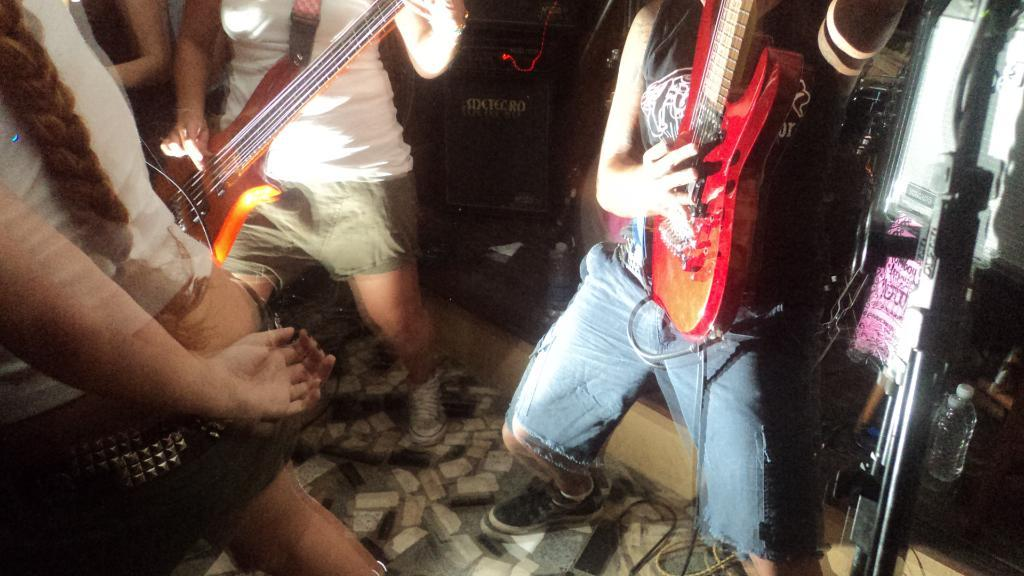How many people are in the image? There are persons in the image. What are the persons doing in the image? The persons are holding musical instruments and playing them. Can you see a giraffe playing a musical instrument in the image? No, there is no giraffe present in the image. 